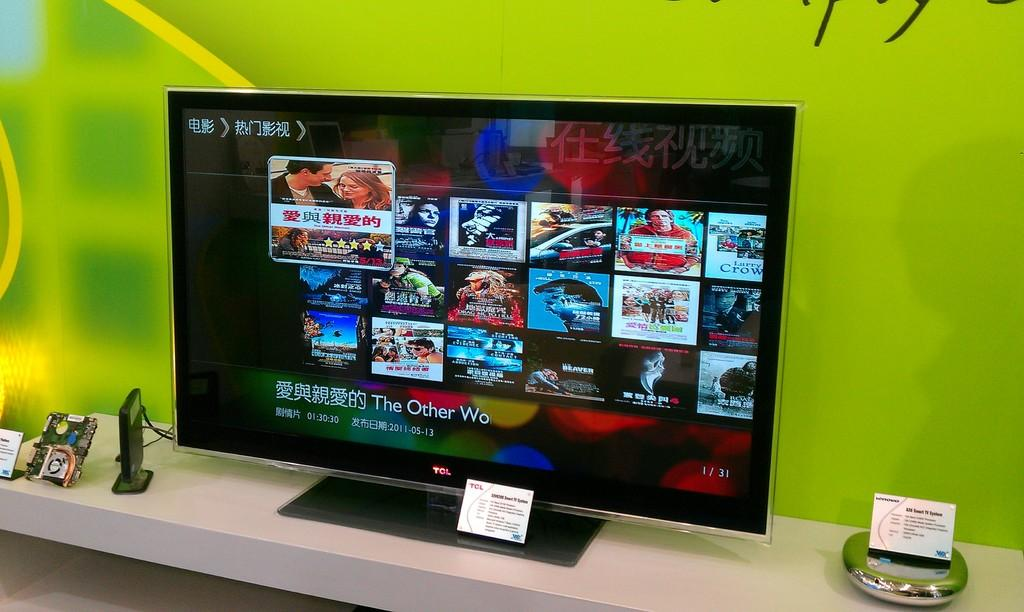<image>
Create a compact narrative representing the image presented. A television screen shows several icons and the title The Other Wo. 